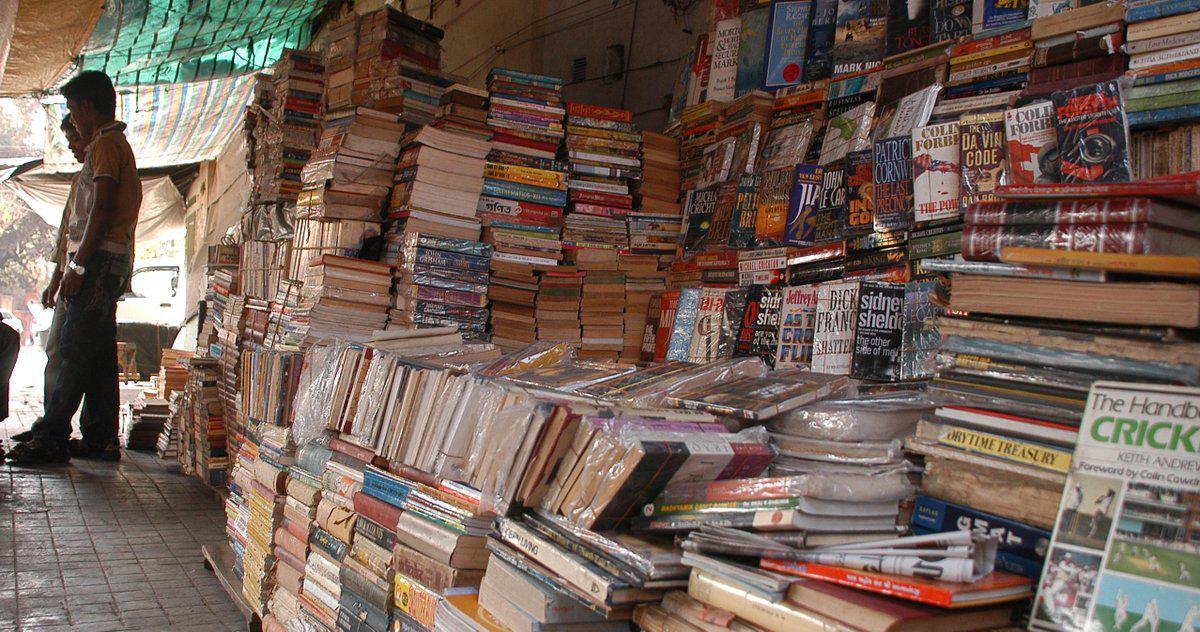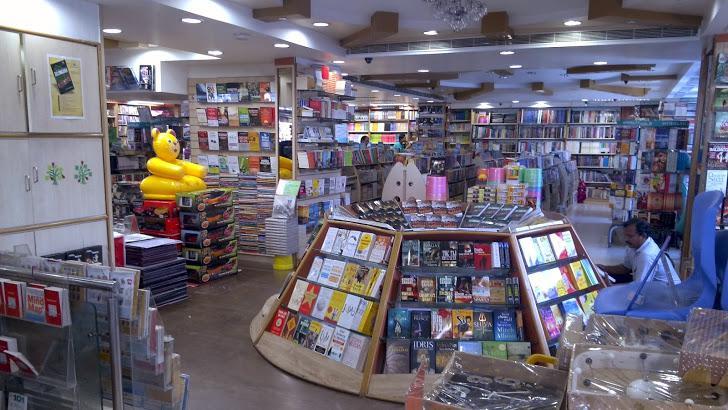The first image is the image on the left, the second image is the image on the right. Analyze the images presented: Is the assertion "One image has a man facing left and looking down." valid? Answer yes or no. Yes. 